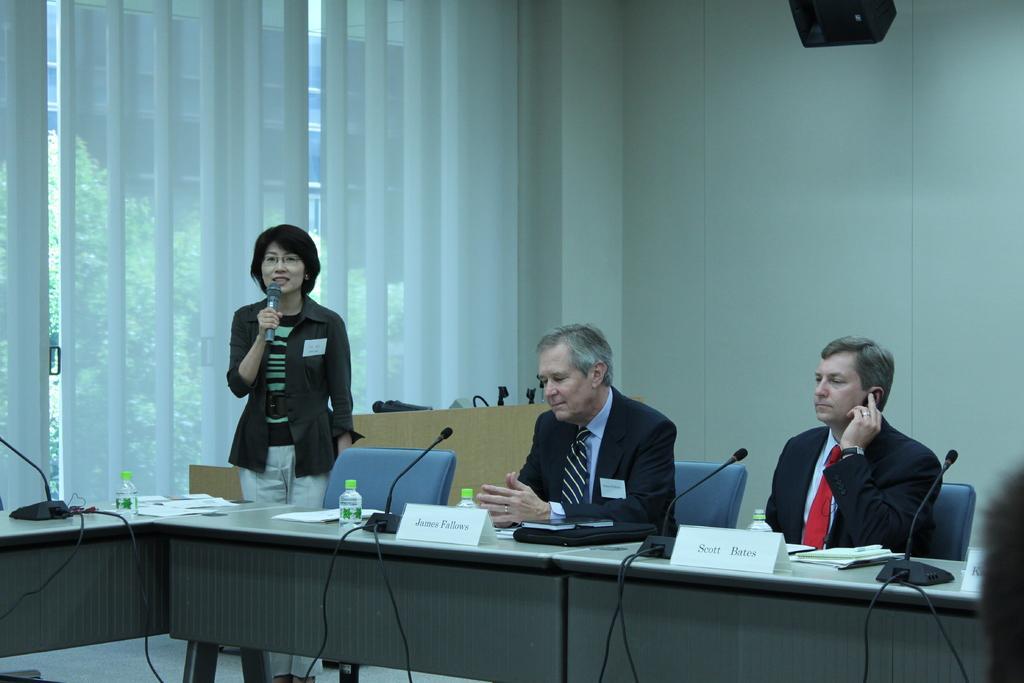Please provide a concise description of this image. In the center of the image there is a table on which there are objects. There are two persons sitting on chair. There is one lady talking in a mic. In the background of the image there is a wall. 